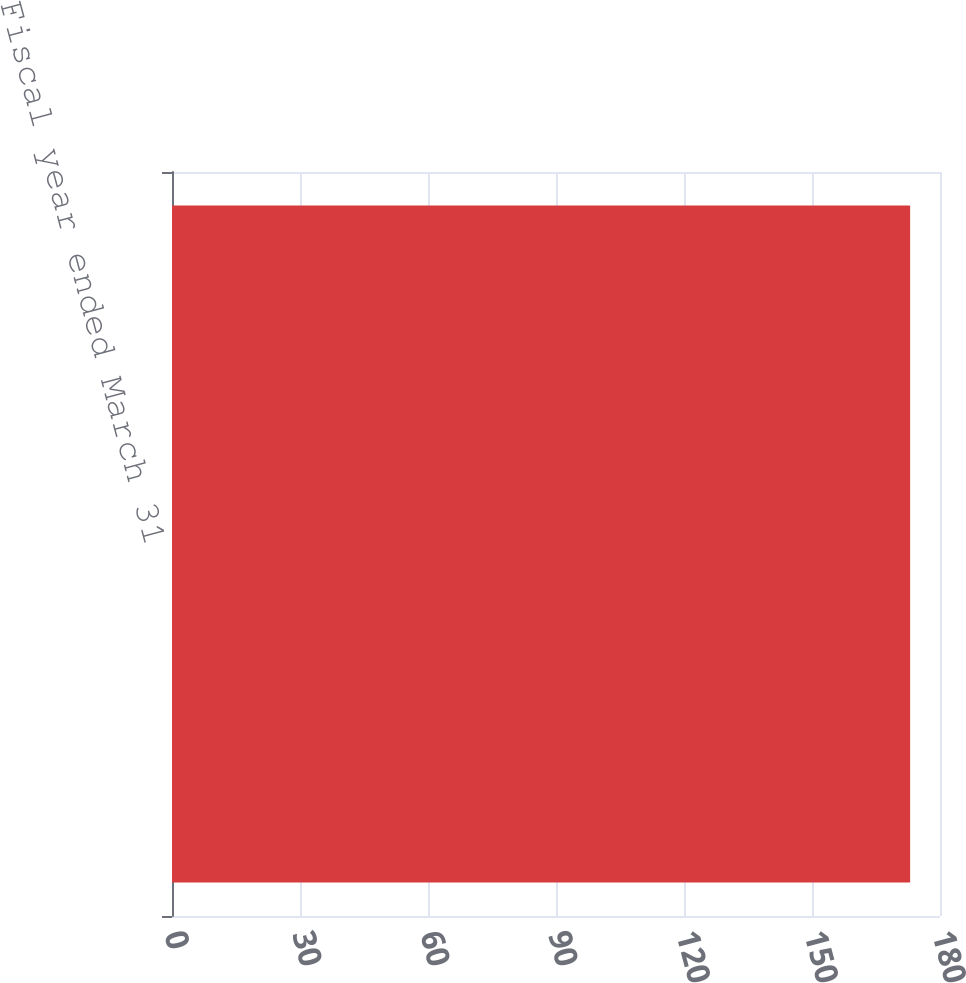Convert chart to OTSL. <chart><loc_0><loc_0><loc_500><loc_500><bar_chart><fcel>Fiscal year ended March 31<nl><fcel>173<nl></chart> 